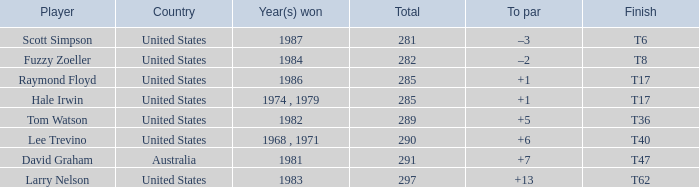What is the year that Hale Irwin won with 285 points? 1974 , 1979. 